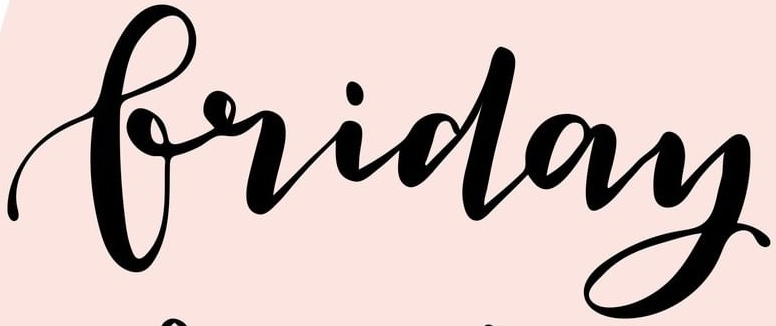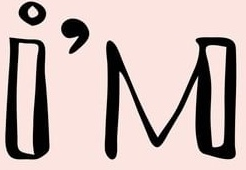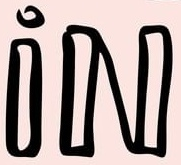Read the text from these images in sequence, separated by a semicolon. Friday; i'M; iN 